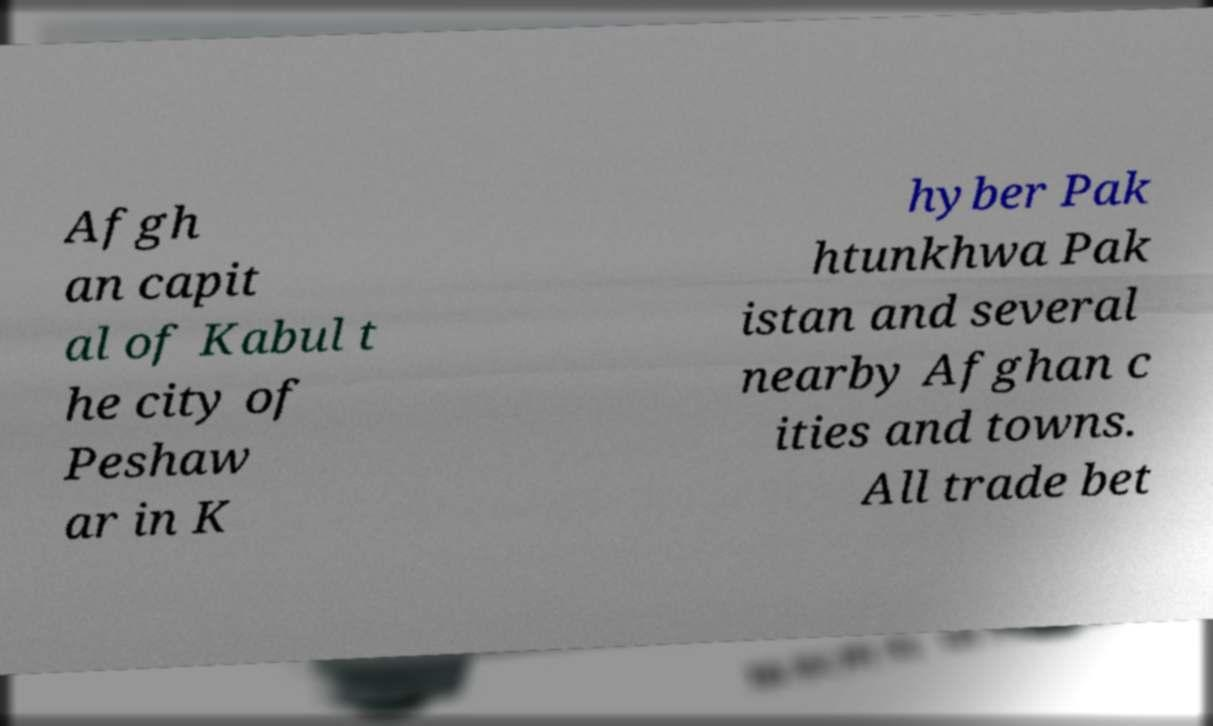I need the written content from this picture converted into text. Can you do that? Afgh an capit al of Kabul t he city of Peshaw ar in K hyber Pak htunkhwa Pak istan and several nearby Afghan c ities and towns. All trade bet 